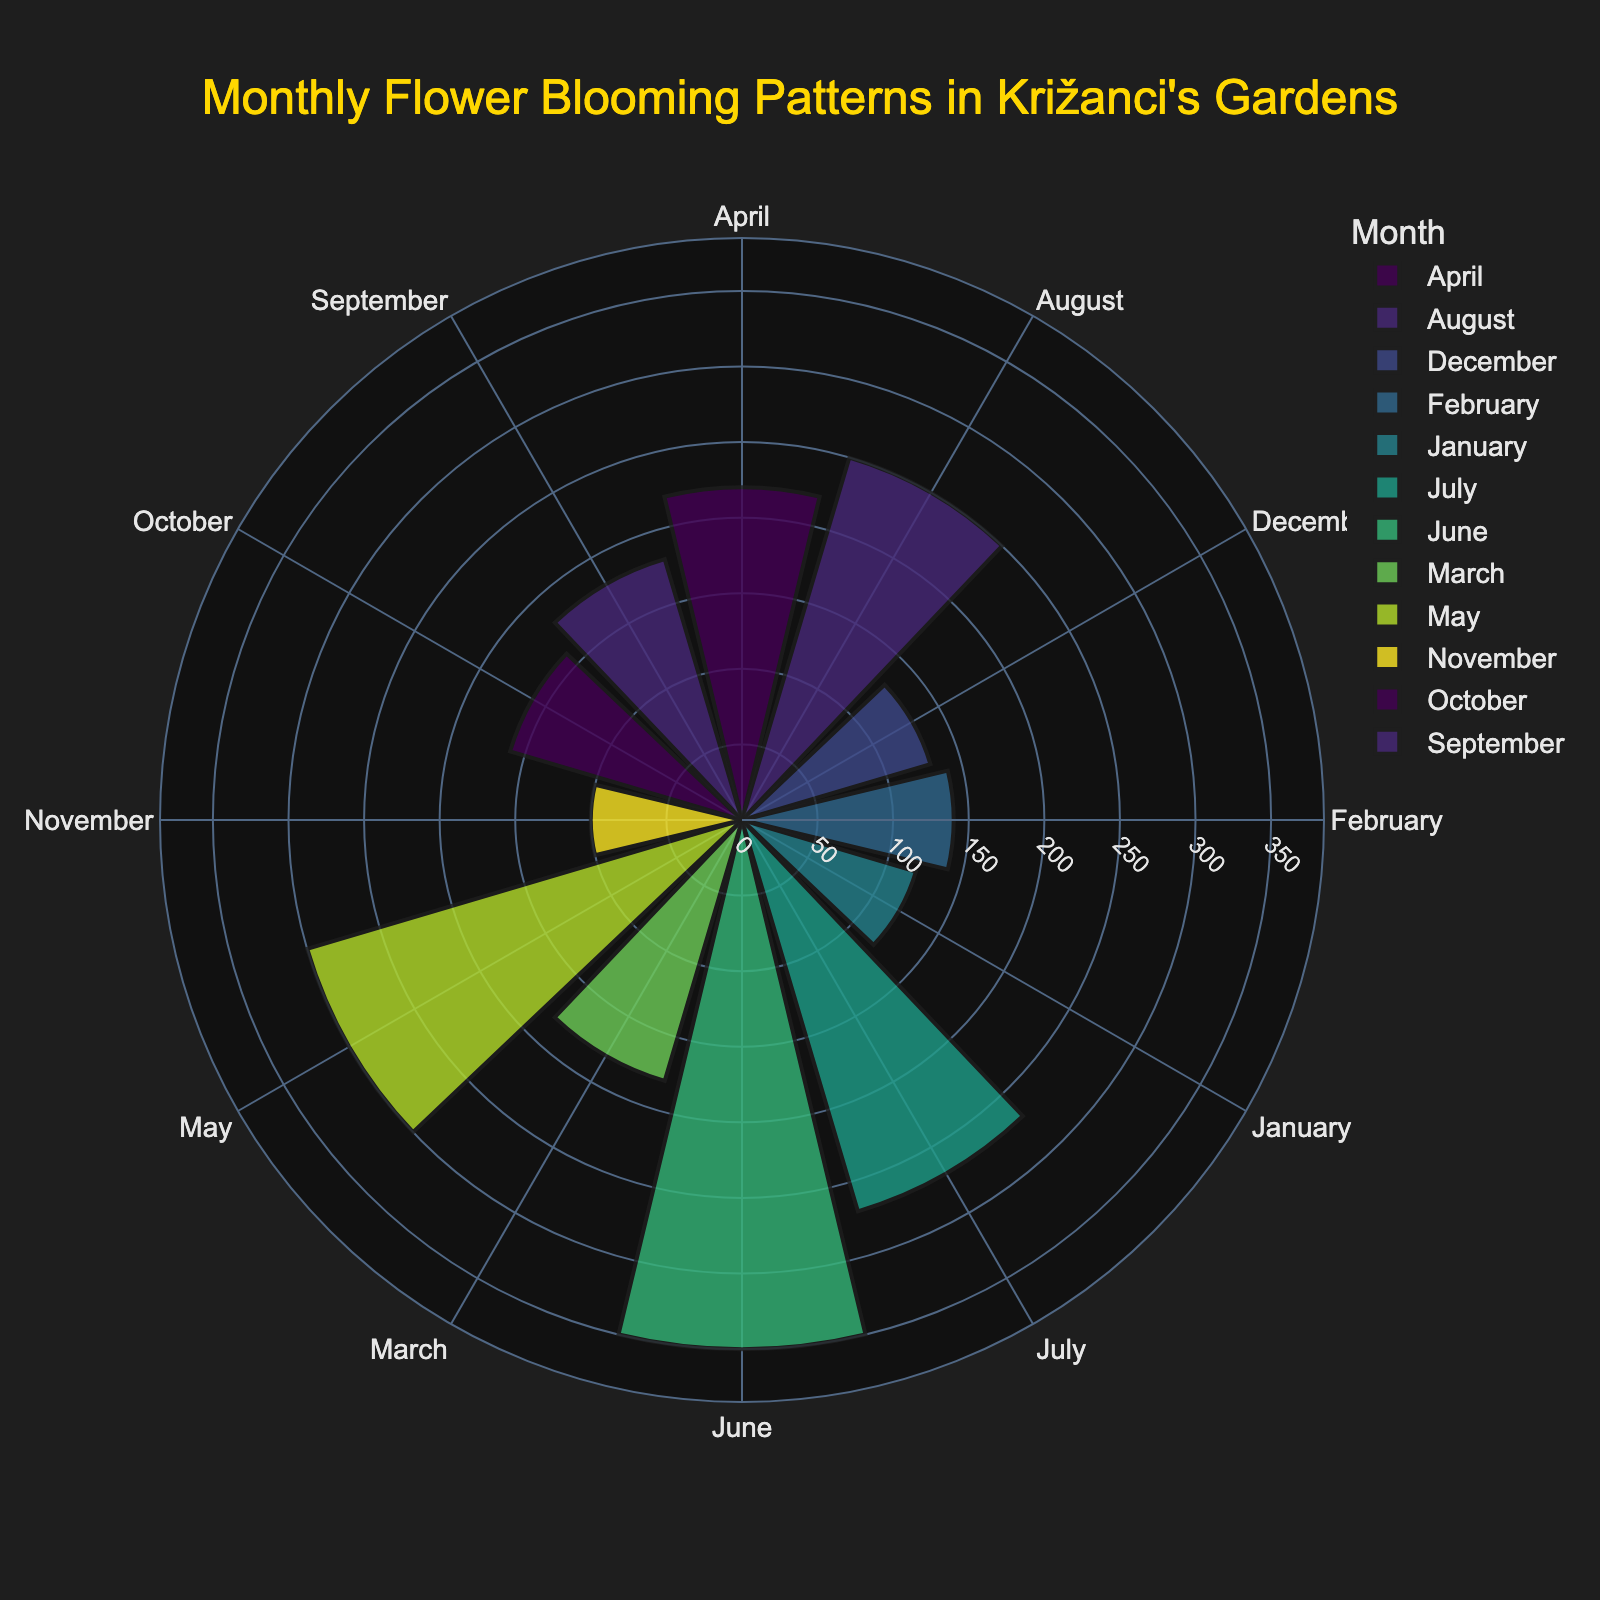What is the title of the rose chart? The title is provided at the top of the rose chart, summarizing what the visual represents.
Answer: Monthly Flower Blooming Patterns in Križanci's Gardens Which month has the highest bloom count? By looking at the rose chart, find the month with the largest bar that extends the furthest radially.
Answer: June Which flower species blooms in Križanci's gardens in February? The flower species blooming in February is represented by Group 1 in the data table. By referring to the group in February, we can see the flower species.
Answer: Winter Jasmine What's the total bloom count for Winter Jasmine across all months? Sum the bloom counts for Winter Jasmine in January, February, and December as per the data table: 120 (Jan) + 140 (Feb) + 130 (Dec).
Answer: 390 Which month has the lowest bloom count? By comparing the lengths of the bars for each month in the rose chart, identify the month with the shortest bar.
Answer: November What is the average bloom count for the months where Chrysanthemum blooms? Locate the months Chrysanthemum blooms in the data table (September and October), sum their bloom counts, and then divide by the number of months: (180 + 160) / 2.
Answer: 170 How does the bloom count in July compare to August? Look at the bloom counts for each month directly from the chart. Compare the lengths of July and August bars.
Answer: July has a higher bloom count than August What's the difference in bloom count between April and November? Subtract the bloom count of November from that of April as per the rose chart data.
Answer: 220 - 100 = 120 In which month does Lavender have the highest bloom count? Check the bloom counts in the rose chart for the months when Lavender is indicated in the data table (July and August). The higher count is in July.
Answer: July Is there a month where more than one flower species is blooming? Each month in the rose chart represents a single species based on their bloom data aggregation, so no month shows multiple species.
Answer: No 